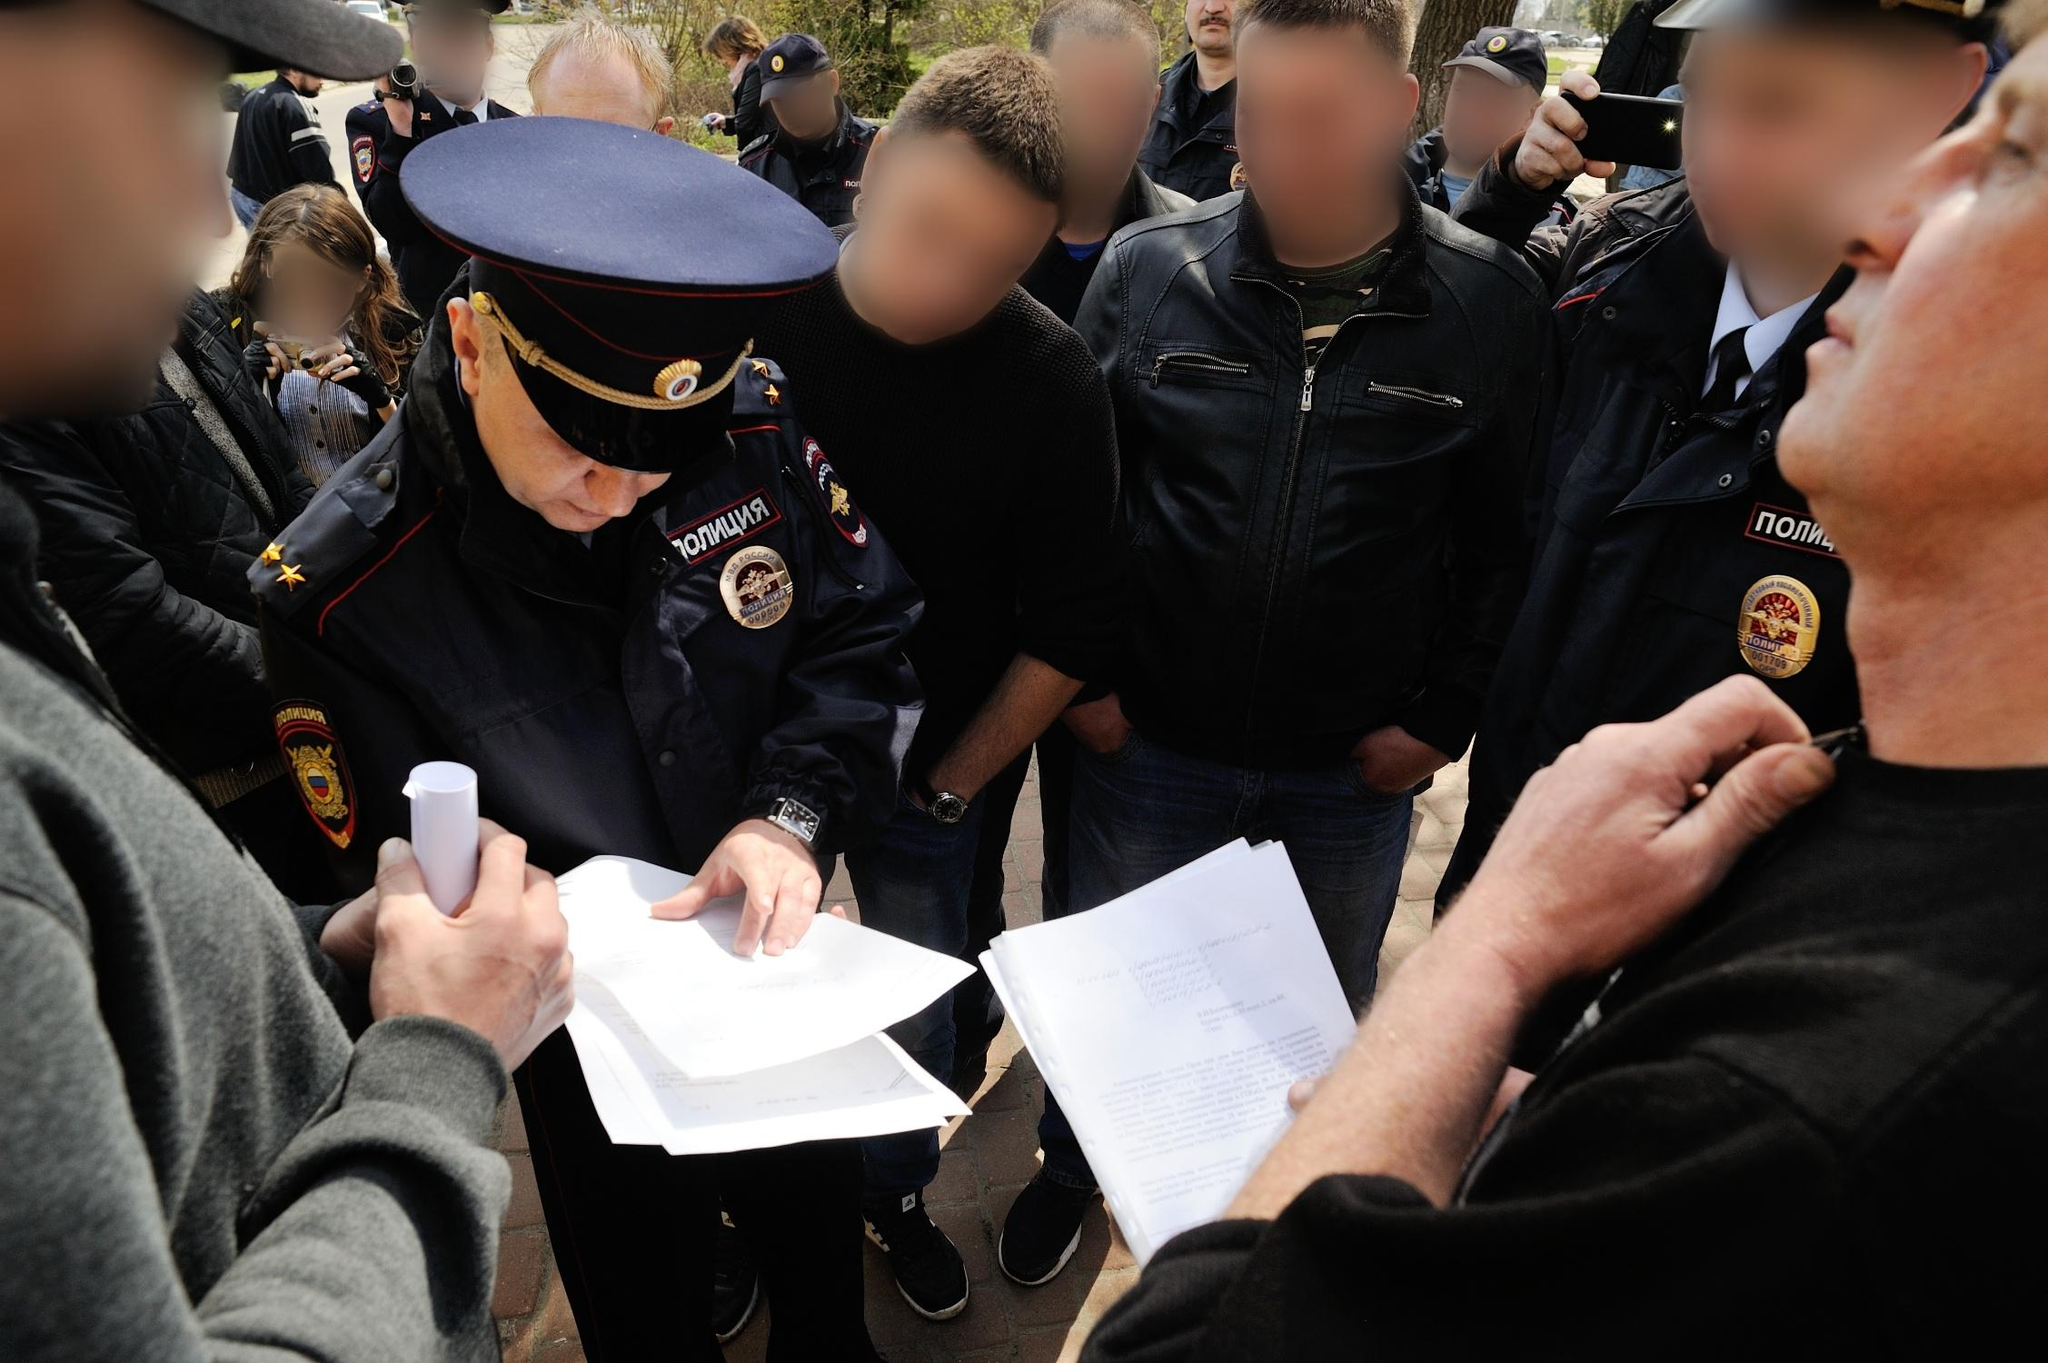What is this photo about? The image depicts a bustling scene centered around an officer dressed in a blue uniform with ornate insignia, highlighting his authoritative role. His red hat and the badge inscribed with 'KOMANDA' accentuate his identification. The officer is focused on writing on white papers, possibly documenting critical information. Surrounding him are people, some with blurred faces, creating a sense of anonymity and focusing the viewer's attention on the officer's actions. On either side of him, there are men dressed in black and red jackets, respectively. The background hints at an outdoor public setting, filled with a crowd and trees, capturing a dynamic moment in what seems like an official gathering or a public event. 